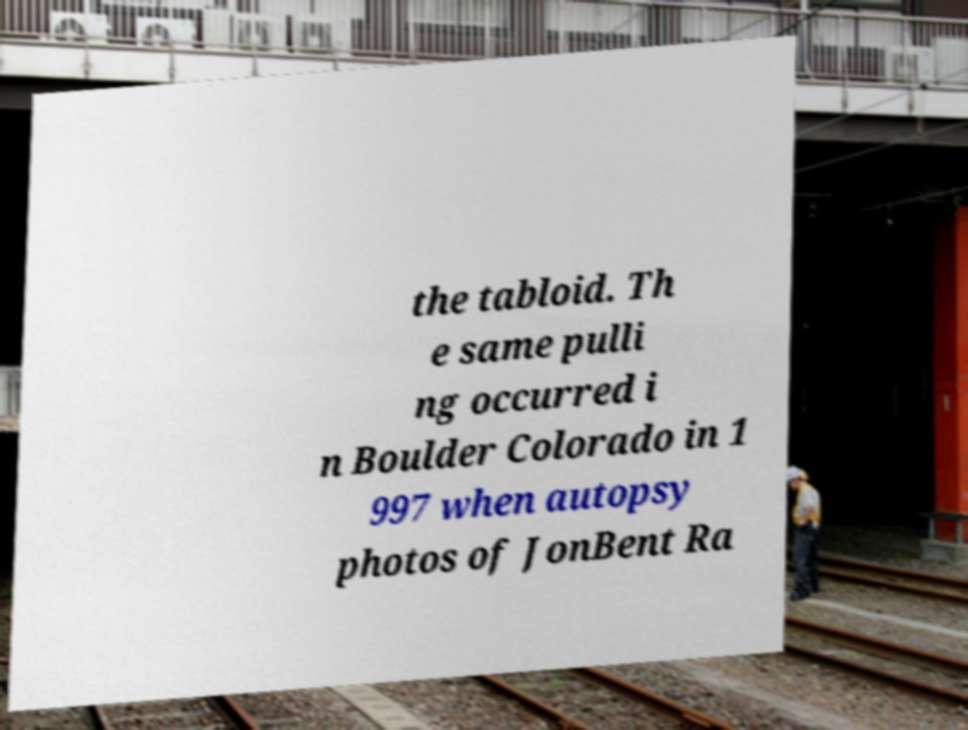Please identify and transcribe the text found in this image. the tabloid. Th e same pulli ng occurred i n Boulder Colorado in 1 997 when autopsy photos of JonBent Ra 